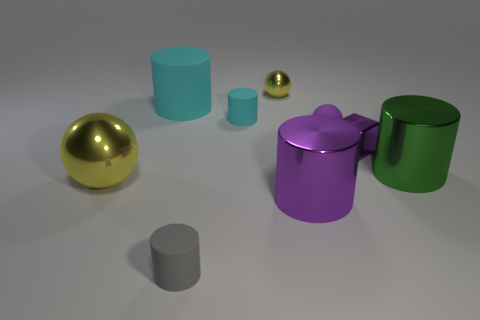There is a purple thing that is the same shape as the large green metal object; what size is it?
Keep it short and to the point. Large. There is a yellow shiny object right of the yellow metallic object that is in front of the big green shiny cylinder; how many tiny balls are in front of it?
Provide a short and direct response. 1. What is the color of the shiny ball left of the tiny matte object in front of the shiny block?
Give a very brief answer. Yellow. How many other things are the same material as the big sphere?
Provide a short and direct response. 4. What number of small balls are to the right of the tiny metallic thing that is behind the tiny cyan thing?
Your response must be concise. 1. Are there any other things that have the same shape as the tiny purple metallic thing?
Offer a very short reply. No. There is a tiny cylinder behind the large yellow thing; is its color the same as the large thing behind the small purple sphere?
Keep it short and to the point. Yes. Are there fewer blue metal balls than tiny shiny blocks?
Your response must be concise. Yes. There is a tiny metallic thing on the right side of the yellow thing right of the big metallic ball; what is its shape?
Give a very brief answer. Cube. What is the shape of the tiny matte thing in front of the tiny shiny thing right of the yellow ball that is to the right of the big rubber cylinder?
Provide a succinct answer. Cylinder. 